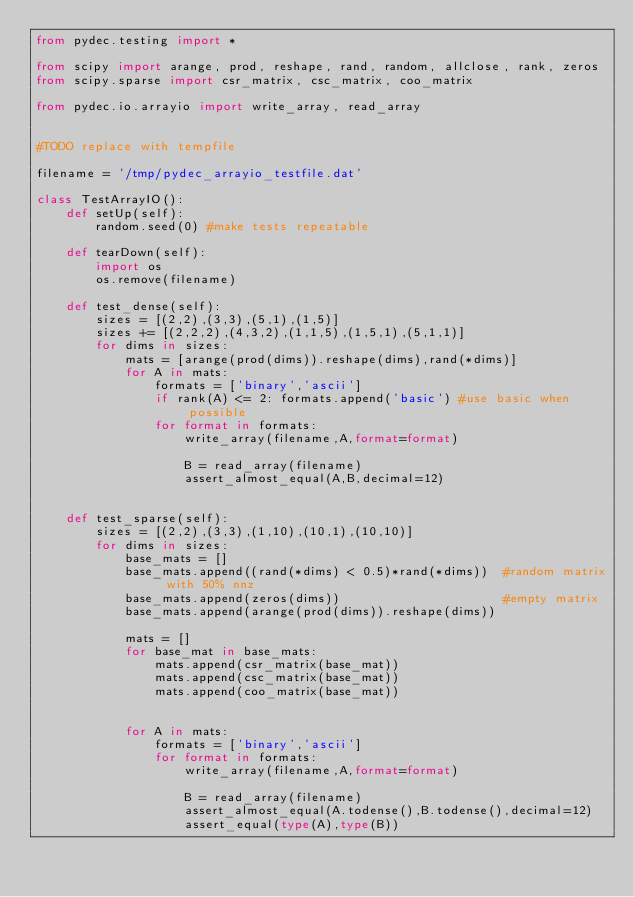Convert code to text. <code><loc_0><loc_0><loc_500><loc_500><_Python_>from pydec.testing import *

from scipy import arange, prod, reshape, rand, random, allclose, rank, zeros
from scipy.sparse import csr_matrix, csc_matrix, coo_matrix

from pydec.io.arrayio import write_array, read_array


#TODO replace with tempfile

filename = '/tmp/pydec_arrayio_testfile.dat'

class TestArrayIO():
    def setUp(self):	
        random.seed(0) #make tests repeatable   
    
    def tearDown(self):
        import os
        os.remove(filename)        

    def test_dense(self):
        sizes = [(2,2),(3,3),(5,1),(1,5)]
        sizes += [(2,2,2),(4,3,2),(1,1,5),(1,5,1),(5,1,1)]
        for dims in sizes:
            mats = [arange(prod(dims)).reshape(dims),rand(*dims)]    
            for A in mats:
                formats = ['binary','ascii']
                if rank(A) <= 2: formats.append('basic') #use basic when possible
                for format in formats:
                    write_array(filename,A,format=format)
                    
                    B = read_array(filename)
                    assert_almost_equal(A,B,decimal=12)


    def test_sparse(self):
        sizes = [(2,2),(3,3),(1,10),(10,1),(10,10)]
        for dims in sizes:
            base_mats = []
            base_mats.append((rand(*dims) < 0.5)*rand(*dims))  #random matrix with 50% nnz
            base_mats.append(zeros(dims))                      #empty matrix
            base_mats.append(arange(prod(dims)).reshape(dims))

            mats = []
            for base_mat in base_mats:
                mats.append(csr_matrix(base_mat))
                mats.append(csc_matrix(base_mat))
                mats.append(coo_matrix(base_mat))
            
            
            for A in mats:
                formats = ['binary','ascii']                        
                for format in formats:
                    write_array(filename,A,format=format)
                    
                    B = read_array(filename)
                    assert_almost_equal(A.todense(),B.todense(),decimal=12)
                    assert_equal(type(A),type(B))

</code> 